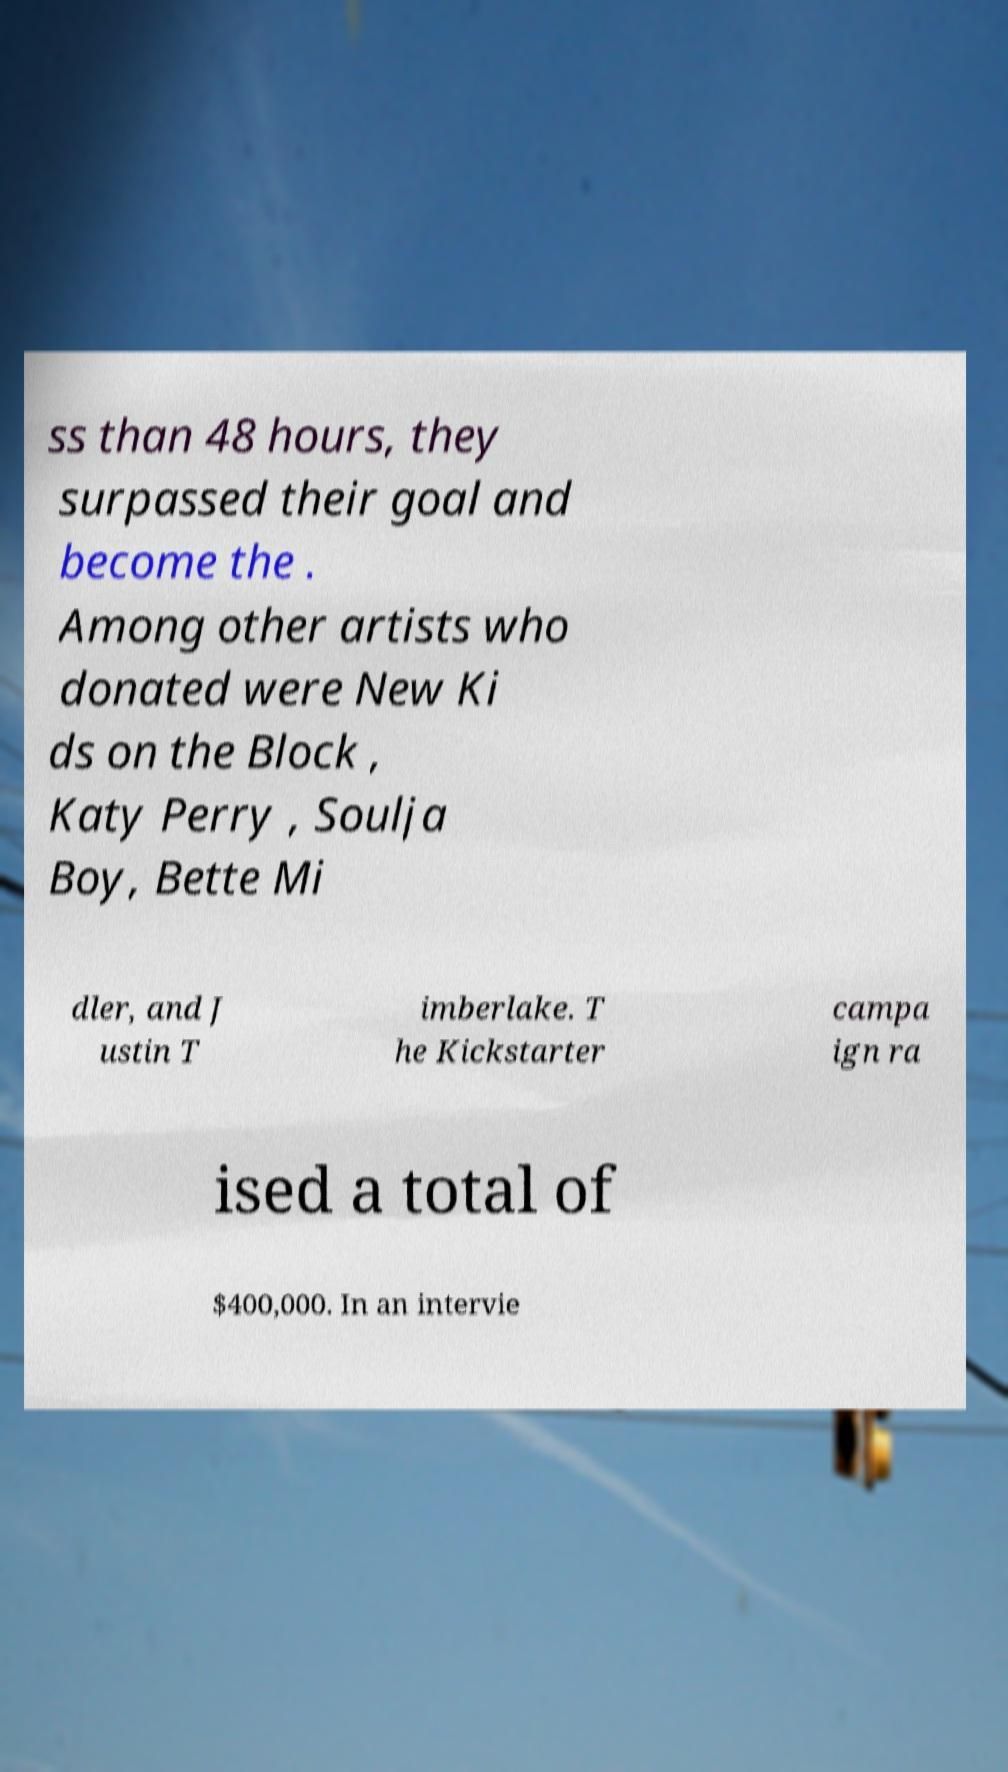For documentation purposes, I need the text within this image transcribed. Could you provide that? ss than 48 hours, they surpassed their goal and become the . Among other artists who donated were New Ki ds on the Block , Katy Perry , Soulja Boy, Bette Mi dler, and J ustin T imberlake. T he Kickstarter campa ign ra ised a total of $400,000. In an intervie 